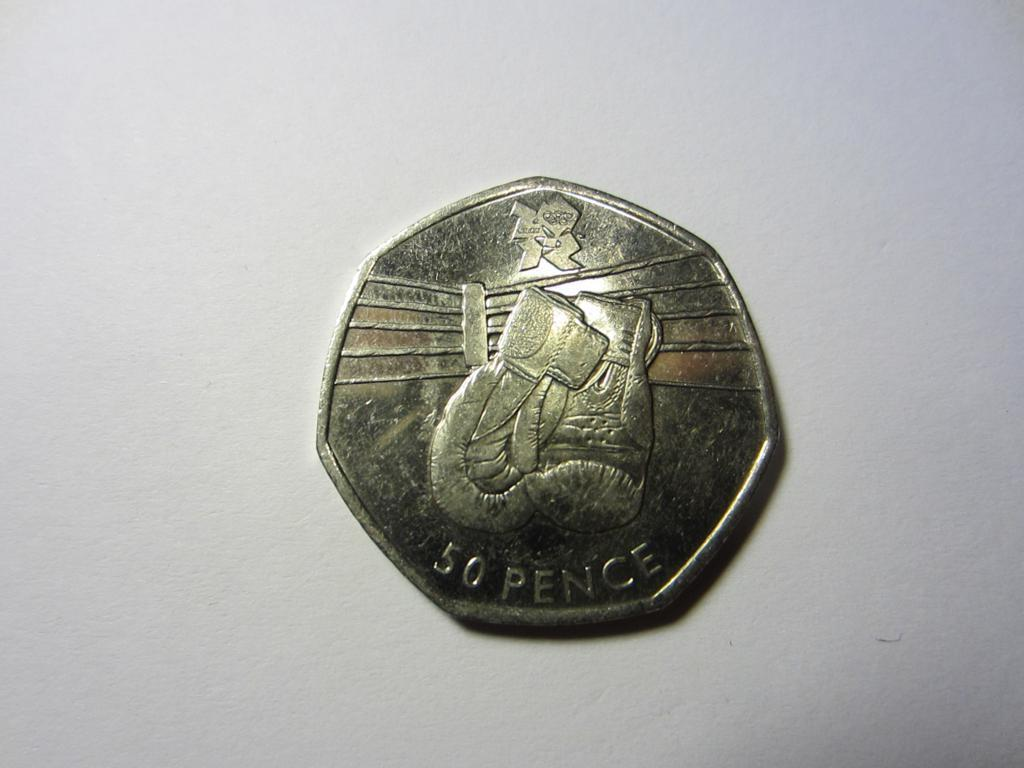<image>
Describe the image concisely. The words on the coin read 50 pence 